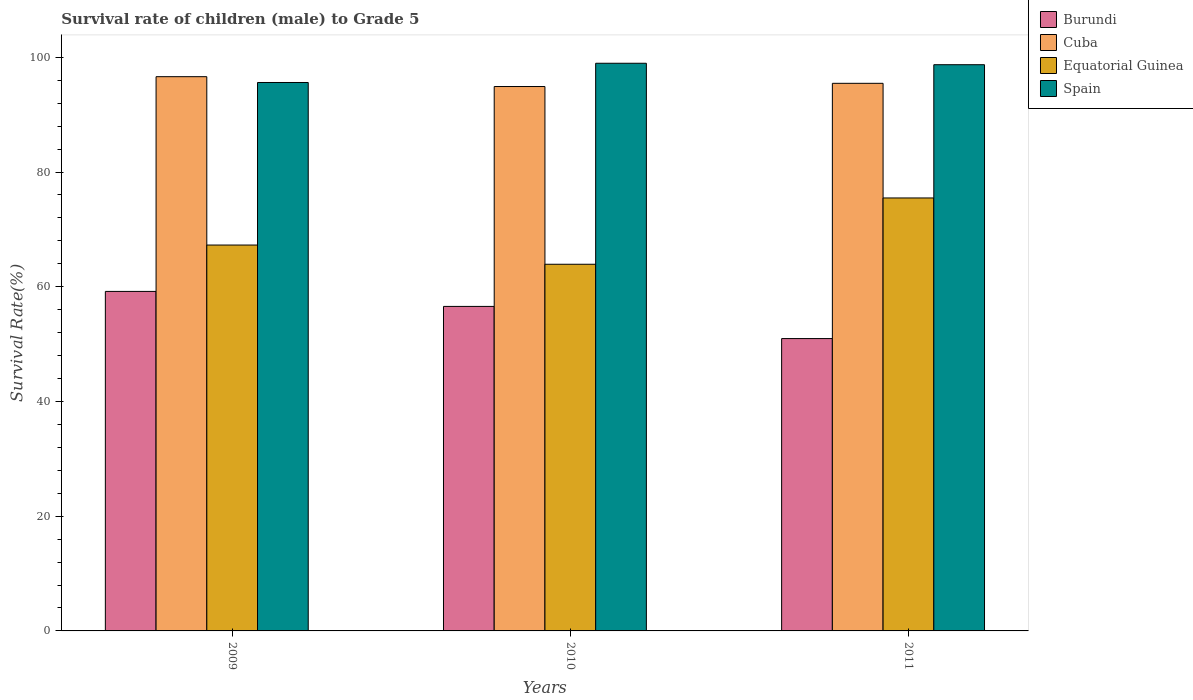How many groups of bars are there?
Give a very brief answer. 3. What is the label of the 3rd group of bars from the left?
Provide a short and direct response. 2011. What is the survival rate of male children to grade 5 in Equatorial Guinea in 2009?
Offer a very short reply. 67.27. Across all years, what is the maximum survival rate of male children to grade 5 in Burundi?
Offer a terse response. 59.19. Across all years, what is the minimum survival rate of male children to grade 5 in Burundi?
Provide a succinct answer. 50.97. In which year was the survival rate of male children to grade 5 in Equatorial Guinea maximum?
Your answer should be very brief. 2011. In which year was the survival rate of male children to grade 5 in Spain minimum?
Keep it short and to the point. 2009. What is the total survival rate of male children to grade 5 in Burundi in the graph?
Your answer should be compact. 166.73. What is the difference between the survival rate of male children to grade 5 in Spain in 2010 and that in 2011?
Provide a succinct answer. 0.25. What is the difference between the survival rate of male children to grade 5 in Spain in 2010 and the survival rate of male children to grade 5 in Burundi in 2009?
Offer a terse response. 39.78. What is the average survival rate of male children to grade 5 in Equatorial Guinea per year?
Provide a succinct answer. 68.89. In the year 2011, what is the difference between the survival rate of male children to grade 5 in Cuba and survival rate of male children to grade 5 in Equatorial Guinea?
Offer a very short reply. 19.98. What is the ratio of the survival rate of male children to grade 5 in Equatorial Guinea in 2010 to that in 2011?
Your answer should be compact. 0.85. Is the survival rate of male children to grade 5 in Cuba in 2009 less than that in 2011?
Ensure brevity in your answer.  No. What is the difference between the highest and the second highest survival rate of male children to grade 5 in Burundi?
Your answer should be very brief. 2.61. What is the difference between the highest and the lowest survival rate of male children to grade 5 in Burundi?
Give a very brief answer. 8.22. Is the sum of the survival rate of male children to grade 5 in Burundi in 2010 and 2011 greater than the maximum survival rate of male children to grade 5 in Cuba across all years?
Give a very brief answer. Yes. Is it the case that in every year, the sum of the survival rate of male children to grade 5 in Equatorial Guinea and survival rate of male children to grade 5 in Burundi is greater than the sum of survival rate of male children to grade 5 in Cuba and survival rate of male children to grade 5 in Spain?
Provide a succinct answer. No. What does the 2nd bar from the left in 2010 represents?
Your answer should be very brief. Cuba. What does the 4th bar from the right in 2011 represents?
Provide a succinct answer. Burundi. How many bars are there?
Ensure brevity in your answer.  12. Are all the bars in the graph horizontal?
Your response must be concise. No. Are the values on the major ticks of Y-axis written in scientific E-notation?
Provide a short and direct response. No. Does the graph contain any zero values?
Give a very brief answer. No. How many legend labels are there?
Offer a terse response. 4. What is the title of the graph?
Keep it short and to the point. Survival rate of children (male) to Grade 5. Does "Guinea" appear as one of the legend labels in the graph?
Give a very brief answer. No. What is the label or title of the X-axis?
Ensure brevity in your answer.  Years. What is the label or title of the Y-axis?
Keep it short and to the point. Survival Rate(%). What is the Survival Rate(%) of Burundi in 2009?
Your answer should be compact. 59.19. What is the Survival Rate(%) in Cuba in 2009?
Provide a short and direct response. 96.62. What is the Survival Rate(%) in Equatorial Guinea in 2009?
Ensure brevity in your answer.  67.27. What is the Survival Rate(%) of Spain in 2009?
Offer a terse response. 95.61. What is the Survival Rate(%) in Burundi in 2010?
Keep it short and to the point. 56.57. What is the Survival Rate(%) in Cuba in 2010?
Offer a terse response. 94.91. What is the Survival Rate(%) of Equatorial Guinea in 2010?
Offer a very short reply. 63.92. What is the Survival Rate(%) of Spain in 2010?
Provide a short and direct response. 98.96. What is the Survival Rate(%) in Burundi in 2011?
Your answer should be compact. 50.97. What is the Survival Rate(%) of Cuba in 2011?
Your answer should be very brief. 95.47. What is the Survival Rate(%) in Equatorial Guinea in 2011?
Keep it short and to the point. 75.48. What is the Survival Rate(%) in Spain in 2011?
Keep it short and to the point. 98.71. Across all years, what is the maximum Survival Rate(%) in Burundi?
Ensure brevity in your answer.  59.19. Across all years, what is the maximum Survival Rate(%) of Cuba?
Your answer should be very brief. 96.62. Across all years, what is the maximum Survival Rate(%) of Equatorial Guinea?
Your answer should be compact. 75.48. Across all years, what is the maximum Survival Rate(%) of Spain?
Keep it short and to the point. 98.96. Across all years, what is the minimum Survival Rate(%) of Burundi?
Your response must be concise. 50.97. Across all years, what is the minimum Survival Rate(%) in Cuba?
Your answer should be very brief. 94.91. Across all years, what is the minimum Survival Rate(%) in Equatorial Guinea?
Offer a terse response. 63.92. Across all years, what is the minimum Survival Rate(%) of Spain?
Offer a terse response. 95.61. What is the total Survival Rate(%) in Burundi in the graph?
Your answer should be compact. 166.73. What is the total Survival Rate(%) of Cuba in the graph?
Keep it short and to the point. 287. What is the total Survival Rate(%) of Equatorial Guinea in the graph?
Provide a short and direct response. 206.68. What is the total Survival Rate(%) of Spain in the graph?
Provide a succinct answer. 293.29. What is the difference between the Survival Rate(%) of Burundi in 2009 and that in 2010?
Give a very brief answer. 2.61. What is the difference between the Survival Rate(%) of Cuba in 2009 and that in 2010?
Ensure brevity in your answer.  1.72. What is the difference between the Survival Rate(%) in Equatorial Guinea in 2009 and that in 2010?
Offer a terse response. 3.35. What is the difference between the Survival Rate(%) in Spain in 2009 and that in 2010?
Provide a short and direct response. -3.35. What is the difference between the Survival Rate(%) in Burundi in 2009 and that in 2011?
Ensure brevity in your answer.  8.22. What is the difference between the Survival Rate(%) of Cuba in 2009 and that in 2011?
Ensure brevity in your answer.  1.16. What is the difference between the Survival Rate(%) in Equatorial Guinea in 2009 and that in 2011?
Your answer should be very brief. -8.21. What is the difference between the Survival Rate(%) in Spain in 2009 and that in 2011?
Make the answer very short. -3.1. What is the difference between the Survival Rate(%) in Burundi in 2010 and that in 2011?
Provide a succinct answer. 5.61. What is the difference between the Survival Rate(%) in Cuba in 2010 and that in 2011?
Your answer should be very brief. -0.56. What is the difference between the Survival Rate(%) in Equatorial Guinea in 2010 and that in 2011?
Keep it short and to the point. -11.56. What is the difference between the Survival Rate(%) of Spain in 2010 and that in 2011?
Your answer should be very brief. 0.25. What is the difference between the Survival Rate(%) in Burundi in 2009 and the Survival Rate(%) in Cuba in 2010?
Offer a very short reply. -35.72. What is the difference between the Survival Rate(%) in Burundi in 2009 and the Survival Rate(%) in Equatorial Guinea in 2010?
Offer a very short reply. -4.74. What is the difference between the Survival Rate(%) of Burundi in 2009 and the Survival Rate(%) of Spain in 2010?
Provide a short and direct response. -39.78. What is the difference between the Survival Rate(%) in Cuba in 2009 and the Survival Rate(%) in Equatorial Guinea in 2010?
Offer a terse response. 32.7. What is the difference between the Survival Rate(%) in Cuba in 2009 and the Survival Rate(%) in Spain in 2010?
Your answer should be very brief. -2.34. What is the difference between the Survival Rate(%) in Equatorial Guinea in 2009 and the Survival Rate(%) in Spain in 2010?
Your answer should be very brief. -31.69. What is the difference between the Survival Rate(%) in Burundi in 2009 and the Survival Rate(%) in Cuba in 2011?
Keep it short and to the point. -36.28. What is the difference between the Survival Rate(%) in Burundi in 2009 and the Survival Rate(%) in Equatorial Guinea in 2011?
Your answer should be compact. -16.29. What is the difference between the Survival Rate(%) of Burundi in 2009 and the Survival Rate(%) of Spain in 2011?
Your answer should be compact. -39.52. What is the difference between the Survival Rate(%) in Cuba in 2009 and the Survival Rate(%) in Equatorial Guinea in 2011?
Make the answer very short. 21.14. What is the difference between the Survival Rate(%) in Cuba in 2009 and the Survival Rate(%) in Spain in 2011?
Offer a terse response. -2.09. What is the difference between the Survival Rate(%) in Equatorial Guinea in 2009 and the Survival Rate(%) in Spain in 2011?
Offer a terse response. -31.44. What is the difference between the Survival Rate(%) of Burundi in 2010 and the Survival Rate(%) of Cuba in 2011?
Make the answer very short. -38.89. What is the difference between the Survival Rate(%) in Burundi in 2010 and the Survival Rate(%) in Equatorial Guinea in 2011?
Give a very brief answer. -18.91. What is the difference between the Survival Rate(%) in Burundi in 2010 and the Survival Rate(%) in Spain in 2011?
Keep it short and to the point. -42.14. What is the difference between the Survival Rate(%) of Cuba in 2010 and the Survival Rate(%) of Equatorial Guinea in 2011?
Your answer should be compact. 19.43. What is the difference between the Survival Rate(%) in Cuba in 2010 and the Survival Rate(%) in Spain in 2011?
Your answer should be very brief. -3.8. What is the difference between the Survival Rate(%) in Equatorial Guinea in 2010 and the Survival Rate(%) in Spain in 2011?
Give a very brief answer. -34.79. What is the average Survival Rate(%) in Burundi per year?
Your answer should be very brief. 55.58. What is the average Survival Rate(%) in Cuba per year?
Your answer should be compact. 95.67. What is the average Survival Rate(%) in Equatorial Guinea per year?
Give a very brief answer. 68.89. What is the average Survival Rate(%) in Spain per year?
Ensure brevity in your answer.  97.76. In the year 2009, what is the difference between the Survival Rate(%) of Burundi and Survival Rate(%) of Cuba?
Your response must be concise. -37.44. In the year 2009, what is the difference between the Survival Rate(%) in Burundi and Survival Rate(%) in Equatorial Guinea?
Ensure brevity in your answer.  -8.09. In the year 2009, what is the difference between the Survival Rate(%) of Burundi and Survival Rate(%) of Spain?
Keep it short and to the point. -36.42. In the year 2009, what is the difference between the Survival Rate(%) of Cuba and Survival Rate(%) of Equatorial Guinea?
Your response must be concise. 29.35. In the year 2009, what is the difference between the Survival Rate(%) of Cuba and Survival Rate(%) of Spain?
Your answer should be very brief. 1.01. In the year 2009, what is the difference between the Survival Rate(%) of Equatorial Guinea and Survival Rate(%) of Spain?
Keep it short and to the point. -28.34. In the year 2010, what is the difference between the Survival Rate(%) of Burundi and Survival Rate(%) of Cuba?
Provide a short and direct response. -38.33. In the year 2010, what is the difference between the Survival Rate(%) in Burundi and Survival Rate(%) in Equatorial Guinea?
Give a very brief answer. -7.35. In the year 2010, what is the difference between the Survival Rate(%) of Burundi and Survival Rate(%) of Spain?
Give a very brief answer. -42.39. In the year 2010, what is the difference between the Survival Rate(%) of Cuba and Survival Rate(%) of Equatorial Guinea?
Provide a succinct answer. 30.98. In the year 2010, what is the difference between the Survival Rate(%) of Cuba and Survival Rate(%) of Spain?
Your response must be concise. -4.06. In the year 2010, what is the difference between the Survival Rate(%) in Equatorial Guinea and Survival Rate(%) in Spain?
Your response must be concise. -35.04. In the year 2011, what is the difference between the Survival Rate(%) in Burundi and Survival Rate(%) in Cuba?
Give a very brief answer. -44.5. In the year 2011, what is the difference between the Survival Rate(%) in Burundi and Survival Rate(%) in Equatorial Guinea?
Provide a short and direct response. -24.51. In the year 2011, what is the difference between the Survival Rate(%) of Burundi and Survival Rate(%) of Spain?
Offer a terse response. -47.74. In the year 2011, what is the difference between the Survival Rate(%) of Cuba and Survival Rate(%) of Equatorial Guinea?
Your answer should be very brief. 19.98. In the year 2011, what is the difference between the Survival Rate(%) of Cuba and Survival Rate(%) of Spain?
Offer a terse response. -3.25. In the year 2011, what is the difference between the Survival Rate(%) of Equatorial Guinea and Survival Rate(%) of Spain?
Offer a terse response. -23.23. What is the ratio of the Survival Rate(%) of Burundi in 2009 to that in 2010?
Make the answer very short. 1.05. What is the ratio of the Survival Rate(%) in Cuba in 2009 to that in 2010?
Provide a succinct answer. 1.02. What is the ratio of the Survival Rate(%) in Equatorial Guinea in 2009 to that in 2010?
Ensure brevity in your answer.  1.05. What is the ratio of the Survival Rate(%) of Spain in 2009 to that in 2010?
Offer a terse response. 0.97. What is the ratio of the Survival Rate(%) of Burundi in 2009 to that in 2011?
Make the answer very short. 1.16. What is the ratio of the Survival Rate(%) of Cuba in 2009 to that in 2011?
Provide a succinct answer. 1.01. What is the ratio of the Survival Rate(%) in Equatorial Guinea in 2009 to that in 2011?
Provide a succinct answer. 0.89. What is the ratio of the Survival Rate(%) in Spain in 2009 to that in 2011?
Your response must be concise. 0.97. What is the ratio of the Survival Rate(%) of Burundi in 2010 to that in 2011?
Ensure brevity in your answer.  1.11. What is the ratio of the Survival Rate(%) of Cuba in 2010 to that in 2011?
Ensure brevity in your answer.  0.99. What is the ratio of the Survival Rate(%) in Equatorial Guinea in 2010 to that in 2011?
Offer a very short reply. 0.85. What is the ratio of the Survival Rate(%) of Spain in 2010 to that in 2011?
Offer a terse response. 1. What is the difference between the highest and the second highest Survival Rate(%) of Burundi?
Make the answer very short. 2.61. What is the difference between the highest and the second highest Survival Rate(%) in Cuba?
Offer a very short reply. 1.16. What is the difference between the highest and the second highest Survival Rate(%) in Equatorial Guinea?
Offer a very short reply. 8.21. What is the difference between the highest and the second highest Survival Rate(%) in Spain?
Ensure brevity in your answer.  0.25. What is the difference between the highest and the lowest Survival Rate(%) of Burundi?
Your answer should be very brief. 8.22. What is the difference between the highest and the lowest Survival Rate(%) of Cuba?
Your answer should be very brief. 1.72. What is the difference between the highest and the lowest Survival Rate(%) of Equatorial Guinea?
Your response must be concise. 11.56. What is the difference between the highest and the lowest Survival Rate(%) in Spain?
Your answer should be compact. 3.35. 